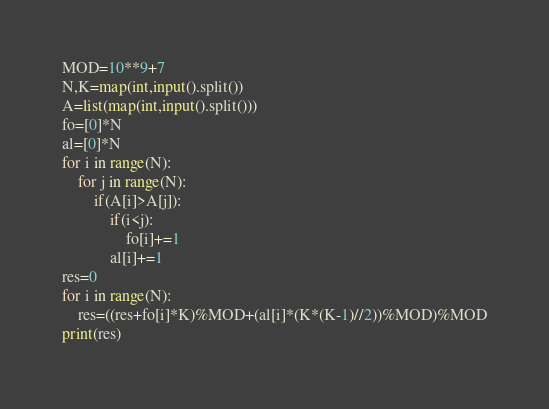<code> <loc_0><loc_0><loc_500><loc_500><_Python_>MOD=10**9+7
N,K=map(int,input().split())
A=list(map(int,input().split()))
fo=[0]*N
al=[0]*N
for i in range(N):
    for j in range(N):
        if(A[i]>A[j]):
            if(i<j):
                fo[i]+=1
            al[i]+=1
res=0
for i in range(N):
    res=((res+fo[i]*K)%MOD+(al[i]*(K*(K-1)//2))%MOD)%MOD
print(res)</code> 